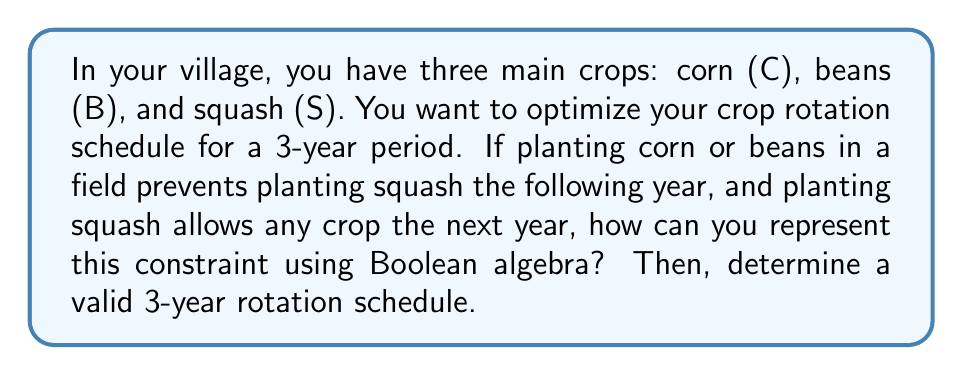Can you answer this question? Let's approach this step-by-step using Boolean algebra:

1) First, we'll define our variables for each year:
   $C_i, B_i, S_i$ where $i = 1, 2, 3$ represents the year

2) The constraint can be represented as:
   $$(C_i + B_i) \rightarrow \neg S_{i+1}$$
   This means if we plant corn or beans in year $i$, we cannot plant squash in year $i+1$

3) We can convert this implication to its equivalent disjunctive form:
   $$\neg(C_i + B_i) + \neg S_{i+1}$$

4) Using De Morgan's law, this becomes:
   $$(\neg C_i \cdot \neg B_i) + \neg S_{i+1}$$

5) Now, we need to ensure that only one crop is planted each year:
   $$(C_i \oplus B_i \oplus S_i) = 1$$ for $i = 1, 2, 3$

6) Combining these constraints for all years:
   $$[(\neg C_1 \cdot \neg B_1) + \neg S_2] \cdot [(\neg C_2 \cdot \neg B_2) + \neg S_3] \cdot (C_1 \oplus B_1 \oplus S_1) \cdot (C_2 \oplus B_2 \oplus S_2) \cdot (C_3 \oplus B_3 \oplus S_3) = 1$$

7) One valid solution satisfying this equation is:
   Year 1: Squash $(S_1 = 1, C_1 = B_1 = 0)$
   Year 2: Corn $(C_2 = 1, B_2 = S_2 = 0)$
   Year 3: Beans $(B_3 = 1, C_3 = S_3 = 0)$

This rotation satisfies all constraints and provides a balanced 3-year schedule.
Answer: S-C-B 